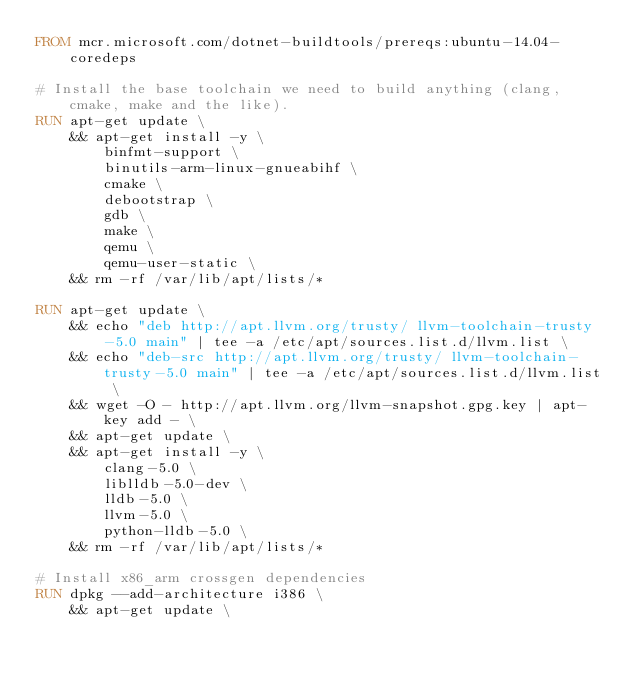Convert code to text. <code><loc_0><loc_0><loc_500><loc_500><_Dockerfile_>FROM mcr.microsoft.com/dotnet-buildtools/prereqs:ubuntu-14.04-coredeps

# Install the base toolchain we need to build anything (clang, cmake, make and the like).
RUN apt-get update \
    && apt-get install -y \
        binfmt-support \
        binutils-arm-linux-gnueabihf \
        cmake \
        debootstrap \
        gdb \
        make \
        qemu \
        qemu-user-static \
    && rm -rf /var/lib/apt/lists/*

RUN apt-get update \
    && echo "deb http://apt.llvm.org/trusty/ llvm-toolchain-trusty-5.0 main" | tee -a /etc/apt/sources.list.d/llvm.list \
    && echo "deb-src http://apt.llvm.org/trusty/ llvm-toolchain-trusty-5.0 main" | tee -a /etc/apt/sources.list.d/llvm.list \
    && wget -O - http://apt.llvm.org/llvm-snapshot.gpg.key | apt-key add - \
    && apt-get update \
    && apt-get install -y \
        clang-5.0 \
        liblldb-5.0-dev \
        lldb-5.0 \
        llvm-5.0 \
        python-lldb-5.0 \
    && rm -rf /var/lib/apt/lists/*

# Install x86_arm crossgen dependencies
RUN dpkg --add-architecture i386 \
    && apt-get update \</code> 